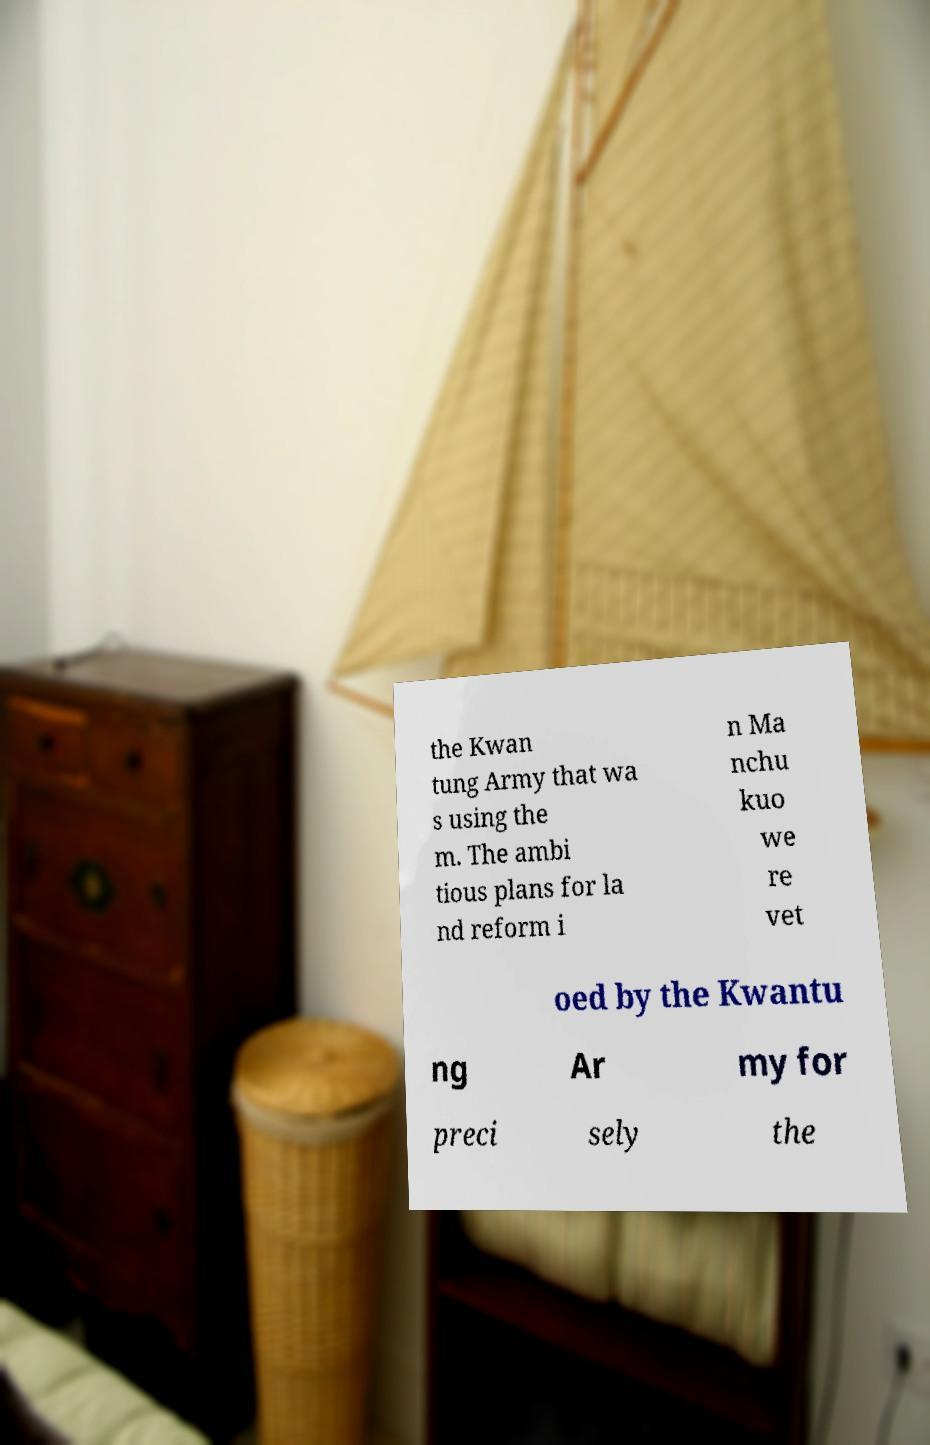For documentation purposes, I need the text within this image transcribed. Could you provide that? the Kwan tung Army that wa s using the m. The ambi tious plans for la nd reform i n Ma nchu kuo we re vet oed by the Kwantu ng Ar my for preci sely the 